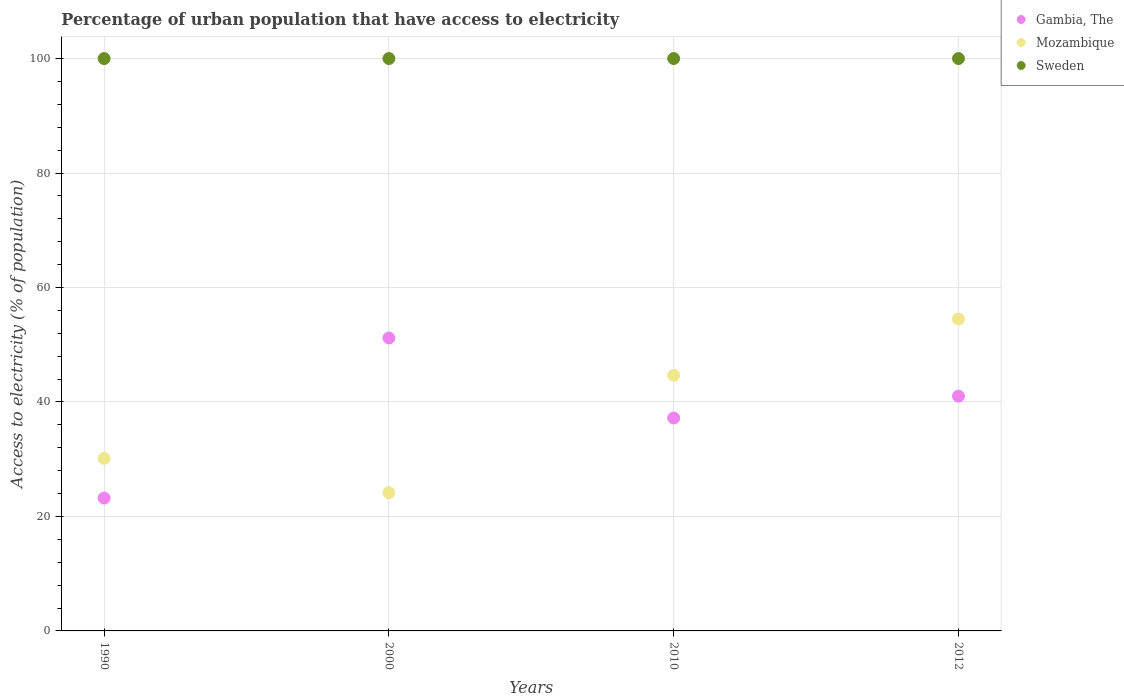Is the number of dotlines equal to the number of legend labels?
Ensure brevity in your answer.  Yes. What is the percentage of urban population that have access to electricity in Gambia, The in 1990?
Give a very brief answer. 23.21. Across all years, what is the maximum percentage of urban population that have access to electricity in Sweden?
Ensure brevity in your answer.  100. Across all years, what is the minimum percentage of urban population that have access to electricity in Mozambique?
Give a very brief answer. 24.16. What is the total percentage of urban population that have access to electricity in Sweden in the graph?
Your answer should be compact. 400. What is the difference between the percentage of urban population that have access to electricity in Gambia, The in 1990 and that in 2012?
Your answer should be very brief. -17.81. What is the difference between the percentage of urban population that have access to electricity in Gambia, The in 2000 and the percentage of urban population that have access to electricity in Sweden in 2010?
Make the answer very short. -48.82. In the year 2010, what is the difference between the percentage of urban population that have access to electricity in Mozambique and percentage of urban population that have access to electricity in Gambia, The?
Your answer should be very brief. 7.46. In how many years, is the percentage of urban population that have access to electricity in Mozambique greater than 72 %?
Your answer should be compact. 0. What is the ratio of the percentage of urban population that have access to electricity in Mozambique in 2000 to that in 2010?
Give a very brief answer. 0.54. What is the difference between the highest and the second highest percentage of urban population that have access to electricity in Mozambique?
Your answer should be compact. 9.84. What is the difference between the highest and the lowest percentage of urban population that have access to electricity in Sweden?
Provide a short and direct response. 0. In how many years, is the percentage of urban population that have access to electricity in Gambia, The greater than the average percentage of urban population that have access to electricity in Gambia, The taken over all years?
Offer a terse response. 2. Is it the case that in every year, the sum of the percentage of urban population that have access to electricity in Gambia, The and percentage of urban population that have access to electricity in Mozambique  is greater than the percentage of urban population that have access to electricity in Sweden?
Keep it short and to the point. No. Does the percentage of urban population that have access to electricity in Sweden monotonically increase over the years?
Provide a short and direct response. No. Is the percentage of urban population that have access to electricity in Sweden strictly greater than the percentage of urban population that have access to electricity in Mozambique over the years?
Keep it short and to the point. Yes. What is the difference between two consecutive major ticks on the Y-axis?
Your response must be concise. 20. Are the values on the major ticks of Y-axis written in scientific E-notation?
Keep it short and to the point. No. Does the graph contain any zero values?
Your answer should be compact. No. Where does the legend appear in the graph?
Your answer should be very brief. Top right. What is the title of the graph?
Keep it short and to the point. Percentage of urban population that have access to electricity. Does "Maldives" appear as one of the legend labels in the graph?
Provide a succinct answer. No. What is the label or title of the Y-axis?
Provide a succinct answer. Access to electricity (% of population). What is the Access to electricity (% of population) of Gambia, The in 1990?
Offer a terse response. 23.21. What is the Access to electricity (% of population) in Mozambique in 1990?
Provide a succinct answer. 30.14. What is the Access to electricity (% of population) of Gambia, The in 2000?
Your answer should be compact. 51.18. What is the Access to electricity (% of population) in Mozambique in 2000?
Offer a terse response. 24.16. What is the Access to electricity (% of population) in Sweden in 2000?
Ensure brevity in your answer.  100. What is the Access to electricity (% of population) of Gambia, The in 2010?
Your response must be concise. 37.2. What is the Access to electricity (% of population) of Mozambique in 2010?
Offer a very short reply. 44.66. What is the Access to electricity (% of population) of Sweden in 2010?
Provide a short and direct response. 100. What is the Access to electricity (% of population) of Gambia, The in 2012?
Your answer should be very brief. 41.01. What is the Access to electricity (% of population) in Mozambique in 2012?
Your answer should be very brief. 54.5. What is the Access to electricity (% of population) in Sweden in 2012?
Give a very brief answer. 100. Across all years, what is the maximum Access to electricity (% of population) in Gambia, The?
Provide a short and direct response. 51.18. Across all years, what is the maximum Access to electricity (% of population) of Mozambique?
Provide a short and direct response. 54.5. Across all years, what is the minimum Access to electricity (% of population) in Gambia, The?
Keep it short and to the point. 23.21. Across all years, what is the minimum Access to electricity (% of population) in Mozambique?
Your answer should be compact. 24.16. Across all years, what is the minimum Access to electricity (% of population) of Sweden?
Give a very brief answer. 100. What is the total Access to electricity (% of population) of Gambia, The in the graph?
Ensure brevity in your answer.  152.6. What is the total Access to electricity (% of population) in Mozambique in the graph?
Your answer should be compact. 153.46. What is the total Access to electricity (% of population) in Sweden in the graph?
Keep it short and to the point. 400. What is the difference between the Access to electricity (% of population) in Gambia, The in 1990 and that in 2000?
Provide a short and direct response. -27.97. What is the difference between the Access to electricity (% of population) in Mozambique in 1990 and that in 2000?
Offer a terse response. 5.99. What is the difference between the Access to electricity (% of population) of Gambia, The in 1990 and that in 2010?
Offer a terse response. -13.99. What is the difference between the Access to electricity (% of population) of Mozambique in 1990 and that in 2010?
Ensure brevity in your answer.  -14.52. What is the difference between the Access to electricity (% of population) of Sweden in 1990 and that in 2010?
Give a very brief answer. 0. What is the difference between the Access to electricity (% of population) in Gambia, The in 1990 and that in 2012?
Your answer should be very brief. -17.81. What is the difference between the Access to electricity (% of population) of Mozambique in 1990 and that in 2012?
Give a very brief answer. -24.36. What is the difference between the Access to electricity (% of population) in Gambia, The in 2000 and that in 2010?
Your answer should be very brief. 13.98. What is the difference between the Access to electricity (% of population) in Mozambique in 2000 and that in 2010?
Make the answer very short. -20.5. What is the difference between the Access to electricity (% of population) of Gambia, The in 2000 and that in 2012?
Offer a terse response. 10.16. What is the difference between the Access to electricity (% of population) in Mozambique in 2000 and that in 2012?
Your answer should be compact. -30.34. What is the difference between the Access to electricity (% of population) in Sweden in 2000 and that in 2012?
Ensure brevity in your answer.  0. What is the difference between the Access to electricity (% of population) of Gambia, The in 2010 and that in 2012?
Your answer should be compact. -3.82. What is the difference between the Access to electricity (% of population) of Mozambique in 2010 and that in 2012?
Keep it short and to the point. -9.84. What is the difference between the Access to electricity (% of population) of Gambia, The in 1990 and the Access to electricity (% of population) of Mozambique in 2000?
Your answer should be very brief. -0.95. What is the difference between the Access to electricity (% of population) in Gambia, The in 1990 and the Access to electricity (% of population) in Sweden in 2000?
Your response must be concise. -76.79. What is the difference between the Access to electricity (% of population) in Mozambique in 1990 and the Access to electricity (% of population) in Sweden in 2000?
Your answer should be compact. -69.86. What is the difference between the Access to electricity (% of population) in Gambia, The in 1990 and the Access to electricity (% of population) in Mozambique in 2010?
Offer a terse response. -21.45. What is the difference between the Access to electricity (% of population) in Gambia, The in 1990 and the Access to electricity (% of population) in Sweden in 2010?
Make the answer very short. -76.79. What is the difference between the Access to electricity (% of population) in Mozambique in 1990 and the Access to electricity (% of population) in Sweden in 2010?
Give a very brief answer. -69.86. What is the difference between the Access to electricity (% of population) of Gambia, The in 1990 and the Access to electricity (% of population) of Mozambique in 2012?
Provide a succinct answer. -31.29. What is the difference between the Access to electricity (% of population) of Gambia, The in 1990 and the Access to electricity (% of population) of Sweden in 2012?
Your response must be concise. -76.79. What is the difference between the Access to electricity (% of population) in Mozambique in 1990 and the Access to electricity (% of population) in Sweden in 2012?
Provide a succinct answer. -69.86. What is the difference between the Access to electricity (% of population) in Gambia, The in 2000 and the Access to electricity (% of population) in Mozambique in 2010?
Give a very brief answer. 6.52. What is the difference between the Access to electricity (% of population) of Gambia, The in 2000 and the Access to electricity (% of population) of Sweden in 2010?
Make the answer very short. -48.82. What is the difference between the Access to electricity (% of population) of Mozambique in 2000 and the Access to electricity (% of population) of Sweden in 2010?
Give a very brief answer. -75.84. What is the difference between the Access to electricity (% of population) in Gambia, The in 2000 and the Access to electricity (% of population) in Mozambique in 2012?
Your answer should be very brief. -3.32. What is the difference between the Access to electricity (% of population) of Gambia, The in 2000 and the Access to electricity (% of population) of Sweden in 2012?
Your response must be concise. -48.82. What is the difference between the Access to electricity (% of population) of Mozambique in 2000 and the Access to electricity (% of population) of Sweden in 2012?
Provide a short and direct response. -75.84. What is the difference between the Access to electricity (% of population) of Gambia, The in 2010 and the Access to electricity (% of population) of Mozambique in 2012?
Your answer should be very brief. -17.3. What is the difference between the Access to electricity (% of population) of Gambia, The in 2010 and the Access to electricity (% of population) of Sweden in 2012?
Make the answer very short. -62.8. What is the difference between the Access to electricity (% of population) in Mozambique in 2010 and the Access to electricity (% of population) in Sweden in 2012?
Keep it short and to the point. -55.34. What is the average Access to electricity (% of population) of Gambia, The per year?
Your response must be concise. 38.15. What is the average Access to electricity (% of population) of Mozambique per year?
Give a very brief answer. 38.37. In the year 1990, what is the difference between the Access to electricity (% of population) in Gambia, The and Access to electricity (% of population) in Mozambique?
Your response must be concise. -6.93. In the year 1990, what is the difference between the Access to electricity (% of population) of Gambia, The and Access to electricity (% of population) of Sweden?
Make the answer very short. -76.79. In the year 1990, what is the difference between the Access to electricity (% of population) in Mozambique and Access to electricity (% of population) in Sweden?
Your answer should be very brief. -69.86. In the year 2000, what is the difference between the Access to electricity (% of population) of Gambia, The and Access to electricity (% of population) of Mozambique?
Your answer should be compact. 27.02. In the year 2000, what is the difference between the Access to electricity (% of population) of Gambia, The and Access to electricity (% of population) of Sweden?
Offer a terse response. -48.82. In the year 2000, what is the difference between the Access to electricity (% of population) of Mozambique and Access to electricity (% of population) of Sweden?
Offer a very short reply. -75.84. In the year 2010, what is the difference between the Access to electricity (% of population) in Gambia, The and Access to electricity (% of population) in Mozambique?
Provide a short and direct response. -7.46. In the year 2010, what is the difference between the Access to electricity (% of population) of Gambia, The and Access to electricity (% of population) of Sweden?
Your answer should be very brief. -62.8. In the year 2010, what is the difference between the Access to electricity (% of population) in Mozambique and Access to electricity (% of population) in Sweden?
Give a very brief answer. -55.34. In the year 2012, what is the difference between the Access to electricity (% of population) of Gambia, The and Access to electricity (% of population) of Mozambique?
Your answer should be compact. -13.49. In the year 2012, what is the difference between the Access to electricity (% of population) of Gambia, The and Access to electricity (% of population) of Sweden?
Your answer should be very brief. -58.99. In the year 2012, what is the difference between the Access to electricity (% of population) in Mozambique and Access to electricity (% of population) in Sweden?
Make the answer very short. -45.5. What is the ratio of the Access to electricity (% of population) of Gambia, The in 1990 to that in 2000?
Your answer should be compact. 0.45. What is the ratio of the Access to electricity (% of population) of Mozambique in 1990 to that in 2000?
Give a very brief answer. 1.25. What is the ratio of the Access to electricity (% of population) in Gambia, The in 1990 to that in 2010?
Provide a succinct answer. 0.62. What is the ratio of the Access to electricity (% of population) in Mozambique in 1990 to that in 2010?
Keep it short and to the point. 0.67. What is the ratio of the Access to electricity (% of population) in Sweden in 1990 to that in 2010?
Keep it short and to the point. 1. What is the ratio of the Access to electricity (% of population) in Gambia, The in 1990 to that in 2012?
Offer a very short reply. 0.57. What is the ratio of the Access to electricity (% of population) in Mozambique in 1990 to that in 2012?
Your answer should be compact. 0.55. What is the ratio of the Access to electricity (% of population) of Gambia, The in 2000 to that in 2010?
Your answer should be very brief. 1.38. What is the ratio of the Access to electricity (% of population) in Mozambique in 2000 to that in 2010?
Make the answer very short. 0.54. What is the ratio of the Access to electricity (% of population) of Sweden in 2000 to that in 2010?
Your answer should be very brief. 1. What is the ratio of the Access to electricity (% of population) of Gambia, The in 2000 to that in 2012?
Ensure brevity in your answer.  1.25. What is the ratio of the Access to electricity (% of population) in Mozambique in 2000 to that in 2012?
Provide a short and direct response. 0.44. What is the ratio of the Access to electricity (% of population) in Gambia, The in 2010 to that in 2012?
Make the answer very short. 0.91. What is the ratio of the Access to electricity (% of population) in Mozambique in 2010 to that in 2012?
Your answer should be compact. 0.82. What is the difference between the highest and the second highest Access to electricity (% of population) of Gambia, The?
Offer a very short reply. 10.16. What is the difference between the highest and the second highest Access to electricity (% of population) in Mozambique?
Provide a succinct answer. 9.84. What is the difference between the highest and the second highest Access to electricity (% of population) in Sweden?
Ensure brevity in your answer.  0. What is the difference between the highest and the lowest Access to electricity (% of population) in Gambia, The?
Keep it short and to the point. 27.97. What is the difference between the highest and the lowest Access to electricity (% of population) in Mozambique?
Your response must be concise. 30.34. 